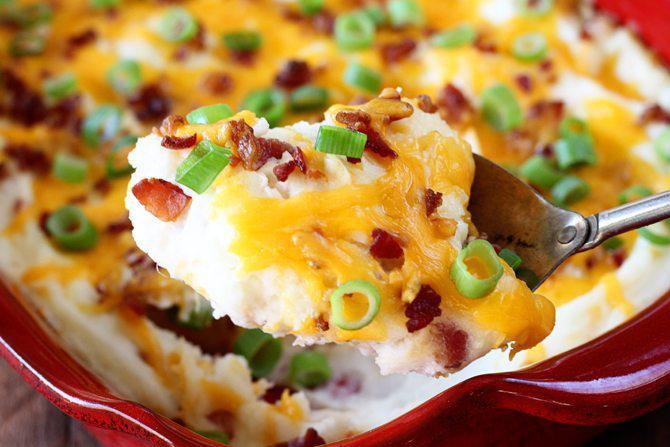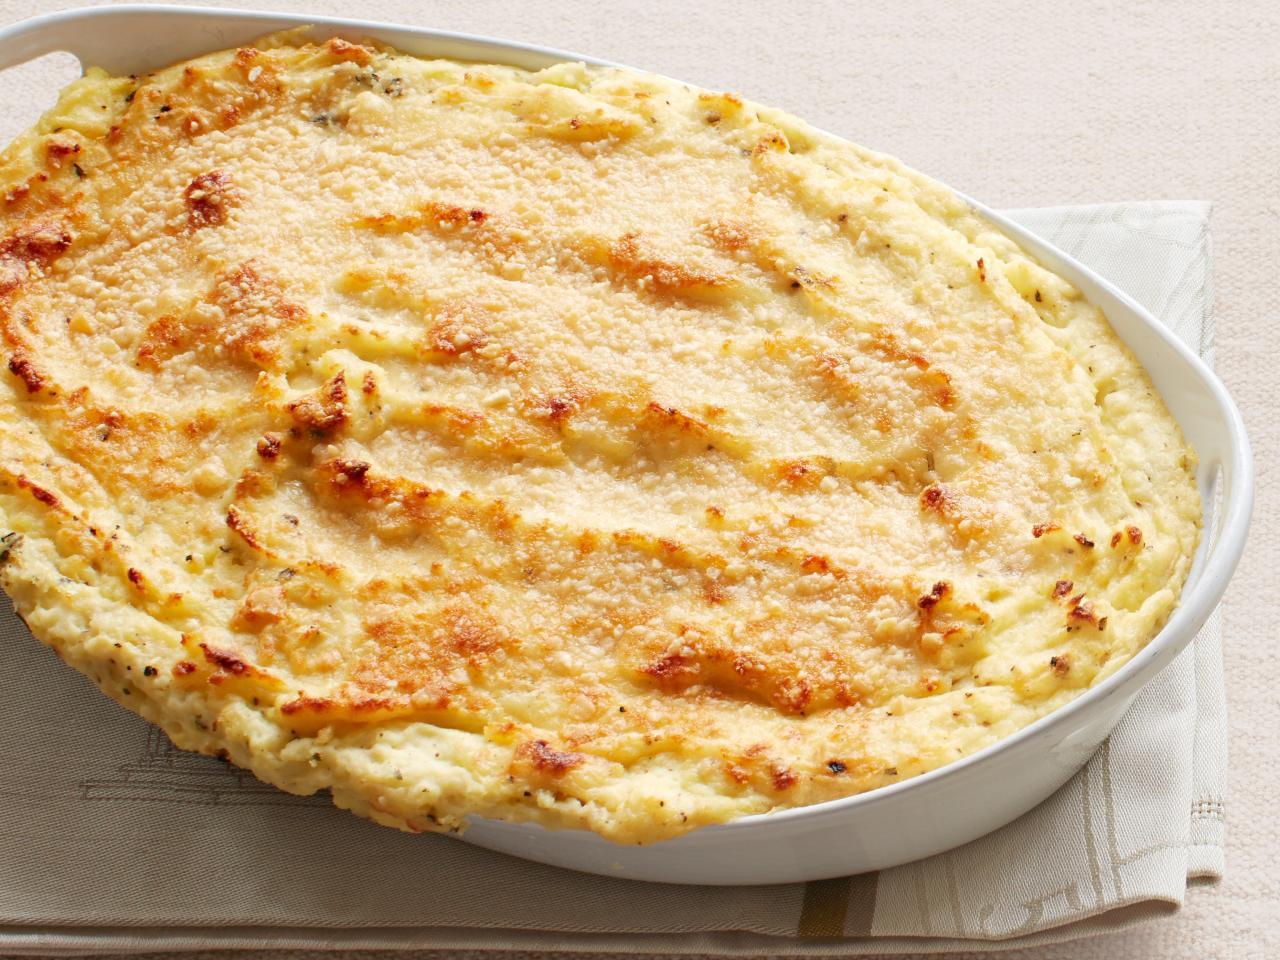The first image is the image on the left, the second image is the image on the right. Given the left and right images, does the statement "The food in one of the images is sitting in a red casserole dish." hold true? Answer yes or no. Yes. The first image is the image on the left, the second image is the image on the right. Considering the images on both sides, is "One image shows a cheese topped casserole in a reddish-orange dish with white interior, and the other image shows a casserole in a solid white dish." valid? Answer yes or no. Yes. 